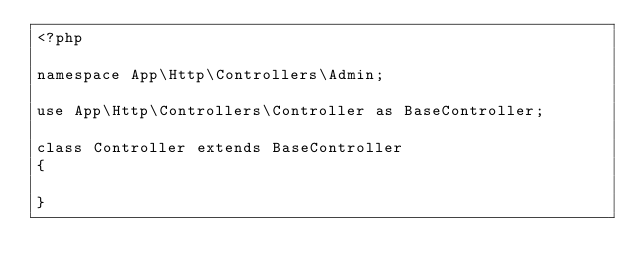Convert code to text. <code><loc_0><loc_0><loc_500><loc_500><_PHP_><?php

namespace App\Http\Controllers\Admin;

use App\Http\Controllers\Controller as BaseController;

class Controller extends BaseController
{

}</code> 